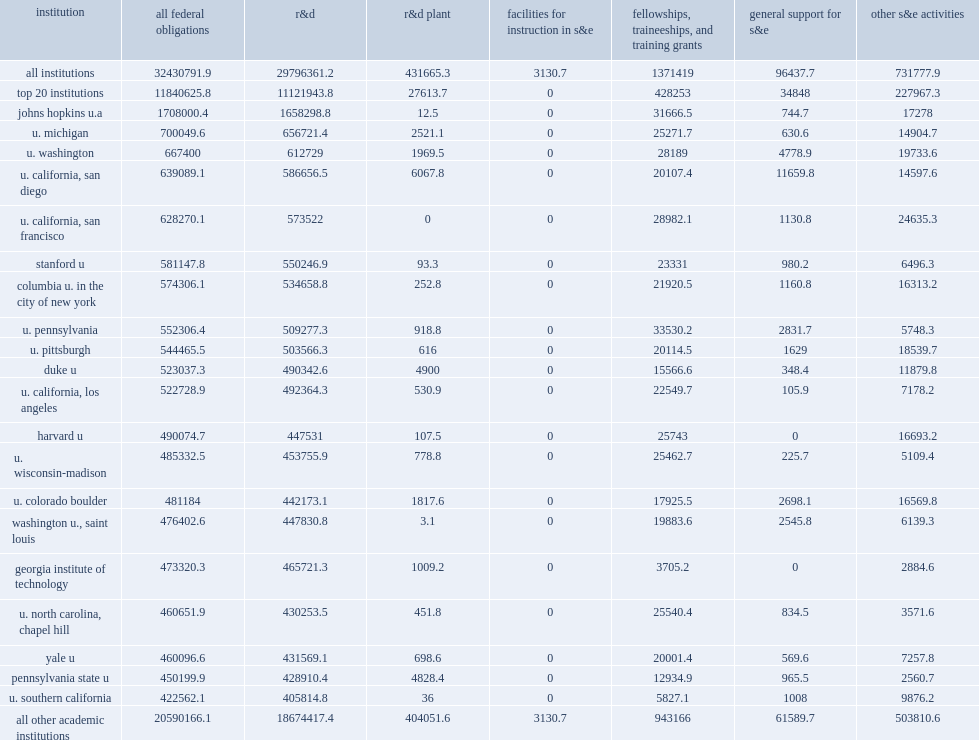How many percentatge points did twenty higher education institutions receiving the largest amounts of federal s&e support account of all s&e support obligations by the federal government? 0.365104. For these 20 academic institutions, how many percentage points of all federal fy 2017 s&e obligations were for r&d? 0.939304. For these 20 academic institutions, how many percentage points of all federal fy 2017 s&e obligations were for fttgs? 0.036168. For these 20 academic institutions, how many percentage points of all federal fy 2017 s&e obligations were for other s&e activities? 0.019253. For these 20 academic institutions, how many percentage points of all federal fy 2017 s&e obligations were for r&d plant? 0.002332. 